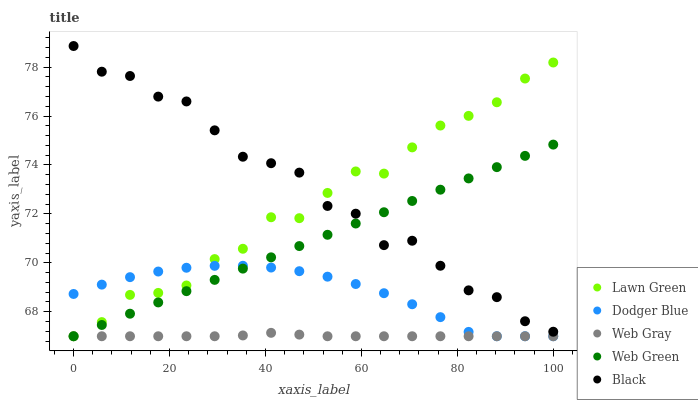Does Web Gray have the minimum area under the curve?
Answer yes or no. Yes. Does Black have the maximum area under the curve?
Answer yes or no. Yes. Does Dodger Blue have the minimum area under the curve?
Answer yes or no. No. Does Dodger Blue have the maximum area under the curve?
Answer yes or no. No. Is Web Green the smoothest?
Answer yes or no. Yes. Is Black the roughest?
Answer yes or no. Yes. Is Web Gray the smoothest?
Answer yes or no. No. Is Web Gray the roughest?
Answer yes or no. No. Does Lawn Green have the lowest value?
Answer yes or no. Yes. Does Black have the lowest value?
Answer yes or no. No. Does Black have the highest value?
Answer yes or no. Yes. Does Dodger Blue have the highest value?
Answer yes or no. No. Is Web Gray less than Black?
Answer yes or no. Yes. Is Black greater than Dodger Blue?
Answer yes or no. Yes. Does Lawn Green intersect Black?
Answer yes or no. Yes. Is Lawn Green less than Black?
Answer yes or no. No. Is Lawn Green greater than Black?
Answer yes or no. No. Does Web Gray intersect Black?
Answer yes or no. No. 